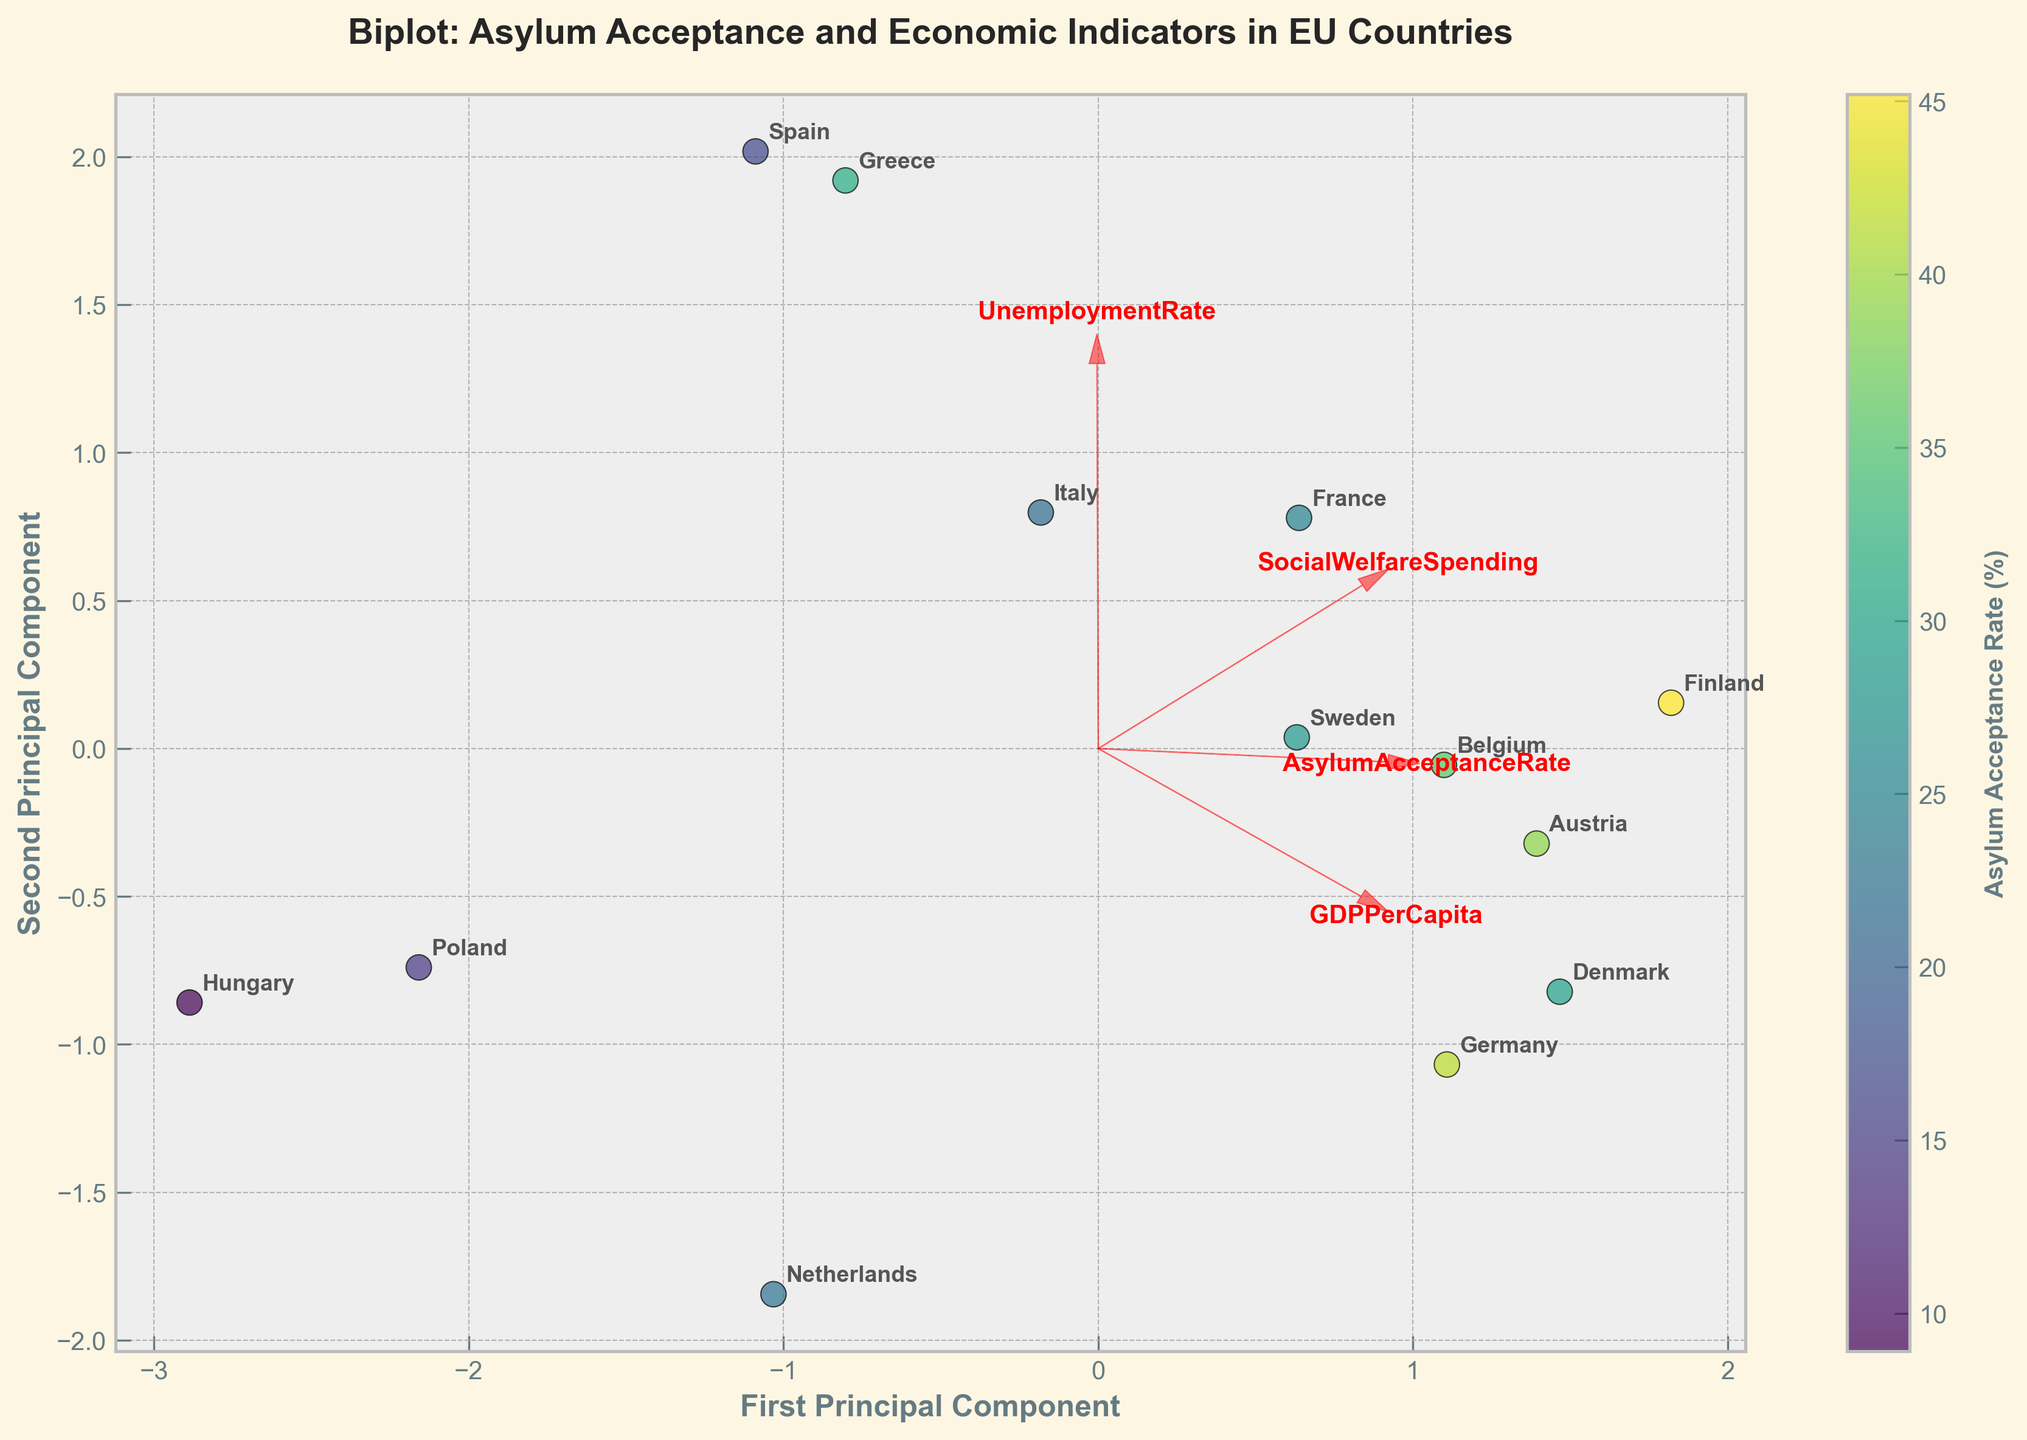What's the title of the figure? The title can be directly read from the top of the figure. It usually describes the main content or purpose of the chart.
Answer: Biplot: Asylum Acceptance and Economic Indicators in EU Countries Which country has the highest Asylum Acceptance Rate according to the color scale? The color scale indicates the Asylum Acceptance Rate, with different colors representing different rates. Looking at the lightest color on the scale and finding the corresponding country will give the answer.
Answer: Finland Which two countries are closest to each other in the Biplot? To determine this, observe the positions of the data points on the plot and identify which two points are nearest to each other.
Answer: Germany and Austria What feature is represented by the arrow pointing most directly along the first principal component axis? Examine the orientation of the arrows (feature vectors) in relation to the first principal component (the x-axis). The feature vector most aligned with this axis identifies the answer.
Answer: GDPPerCapita How does the Unemployment Rate vector compare in length to the Social Welfare Spending vector? Compare the lengths of the vectors (arrows) for Unemployment Rate and Social Welfare Spending to see which one is longer. The length indicates the variance explained by that feature.
Answer: Unemployment Rate vector is shorter Which country has a high GDPPerCapita but a low Asylum Acceptance Rate? First identify countries with high GDP per Capita by looking at the direction and length of the GDPPerCapita vector, then check their corresponding colors for Asylum Acceptance Rate.
Answer: Netherlands Is there a positive or negative relationship between GDPPerCapita and Asylum Acceptance Rate based on the position of countries? Assess the general trend between countries' positioning in relation to the GDPPerCapita vector and the colors indicating Asylum Acceptance Rates.
Answer: Positive relationship Which socioeconomic feature explains the most variability in the data along the second principal component? Evaluate the arrow orientation and length in relation to the second principal component (the y-axis). The longest arrow aligned with this axis indicates the feature.
Answer: UnemploymentRate Based on the plot, which countries have below-average Social Welfare Spending? Identify the Social Welfare Spending vector and see which countries are positioned in the opposite direction or further from this vector.
Answer: Netherlands, Hungary, Poland Are Denmark and Sweden similar in terms of socioeconomic and asylum acceptance indicators? Compare the positions of Denmark and Sweden on the Biplot, along with their color indicators, to determine similarities or differences.
Answer: Somewhat different 